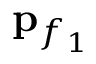Convert formula to latex. <formula><loc_0><loc_0><loc_500><loc_500>{ p } _ { f _ { 1 } }</formula> 